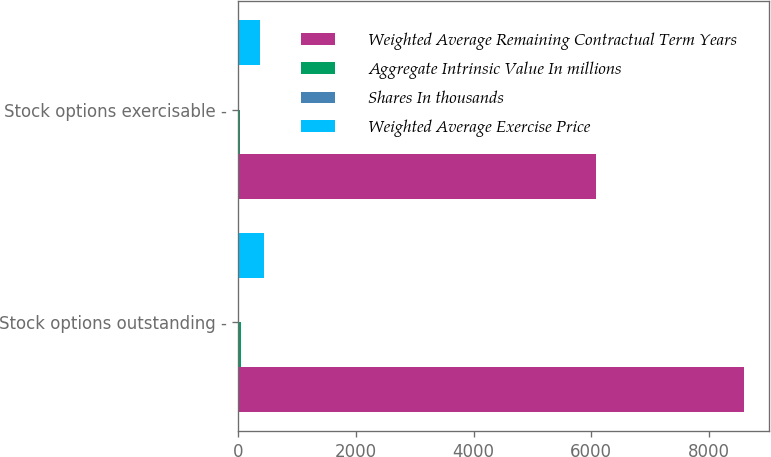Convert chart. <chart><loc_0><loc_0><loc_500><loc_500><stacked_bar_chart><ecel><fcel>Stock options outstanding -<fcel>Stock options exercisable -<nl><fcel>Weighted Average Remaining Contractual Term Years<fcel>8589<fcel>6077<nl><fcel>Aggregate Intrinsic Value In millions<fcel>40<fcel>30.53<nl><fcel>Shares In thousands<fcel>5.8<fcel>4.7<nl><fcel>Weighted Average Exercise Price<fcel>442<fcel>370<nl></chart> 